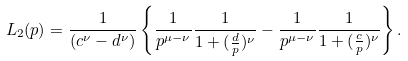<formula> <loc_0><loc_0><loc_500><loc_500>L _ { 2 } ( p ) = \frac { 1 } { ( c ^ { \nu } - d ^ { \nu } ) } \left \{ \frac { 1 } { p ^ { \mu - \nu } } \frac { 1 } { 1 + ( \frac { d } { p } ) ^ { \nu } } - \frac { 1 } { p ^ { \mu - \nu } } \frac { 1 } { 1 + ( \frac { c } { p } ) ^ { \nu } } \right \} .</formula> 